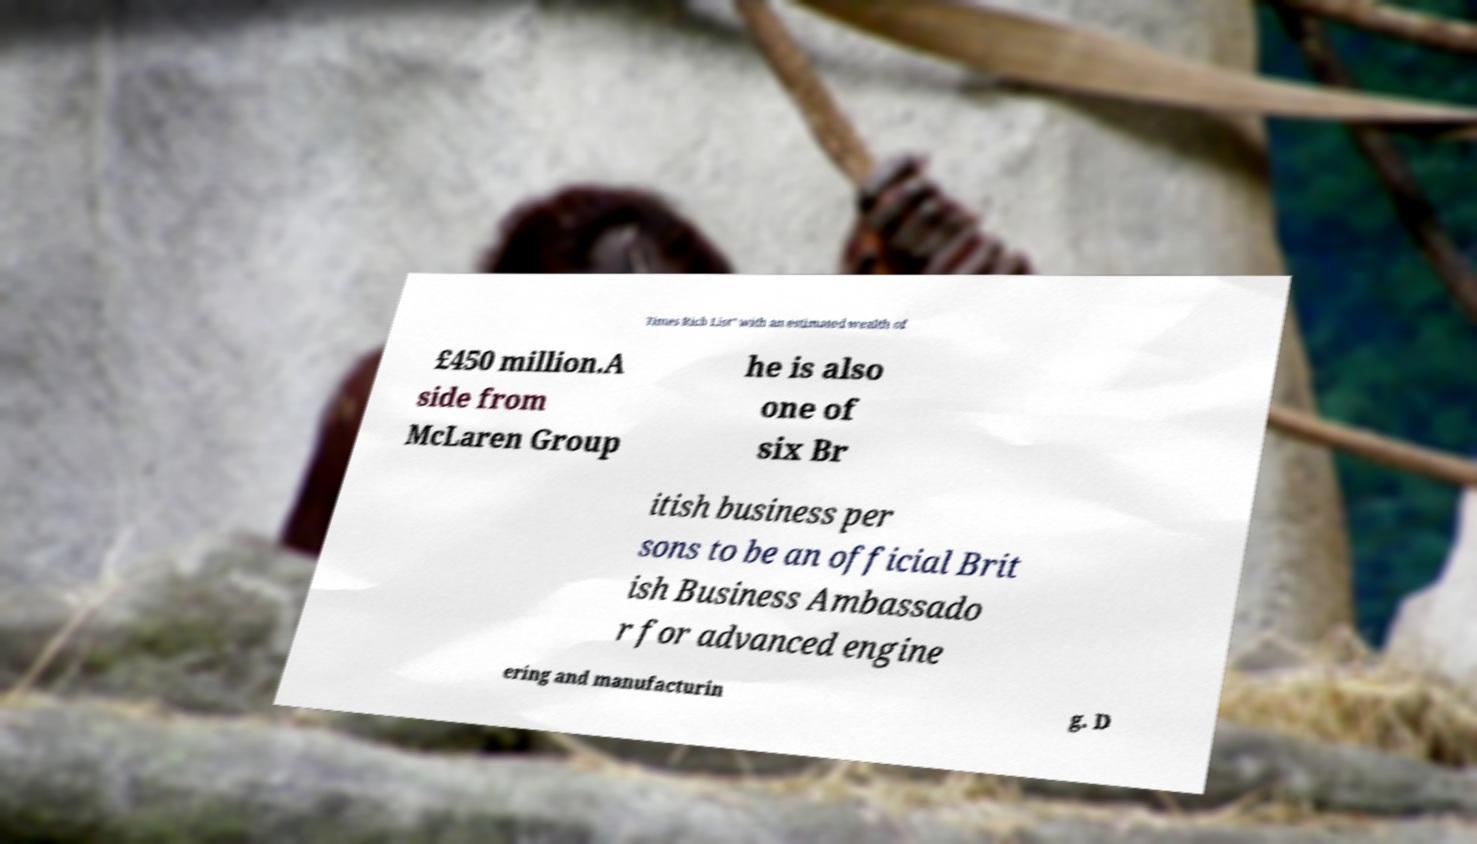For documentation purposes, I need the text within this image transcribed. Could you provide that? Times Rich List" with an estimated wealth of £450 million.A side from McLaren Group he is also one of six Br itish business per sons to be an official Brit ish Business Ambassado r for advanced engine ering and manufacturin g. D 